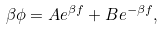<formula> <loc_0><loc_0><loc_500><loc_500>\beta \phi = A e ^ { \beta f } + B e ^ { - \beta f } ,</formula> 